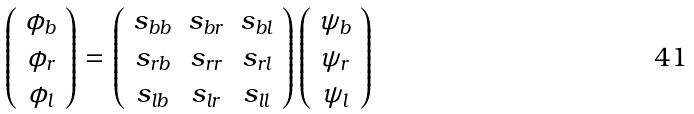Convert formula to latex. <formula><loc_0><loc_0><loc_500><loc_500>\left ( \begin{array} { c } \phi _ { b } \\ \phi _ { r } \\ \phi _ { l } \end{array} \right ) = \left ( \begin{array} { c c c } s _ { b b } & s _ { b r } & s _ { b l } \\ s _ { r b } & s _ { r r } & s _ { r l } \\ s _ { l b } & s _ { l r } & s _ { l l } \end{array} \right ) \left ( \begin{array} { c } \psi _ { b } \\ \psi _ { r } \\ \psi _ { l } \end{array} \right )</formula> 